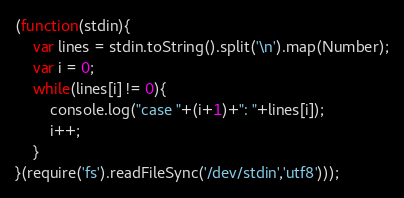Convert code to text. <code><loc_0><loc_0><loc_500><loc_500><_JavaScript_>(function(stdin){
	var lines = stdin.toString().split('\n').map(Number);
	var i = 0;
	while(lines[i] != 0){
		console.log("case "+(i+1)+": "+lines[i]);
		i++;
	}
}(require('fs').readFileSync('/dev/stdin','utf8')));</code> 